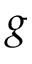Convert formula to latex. <formula><loc_0><loc_0><loc_500><loc_500>g</formula> 